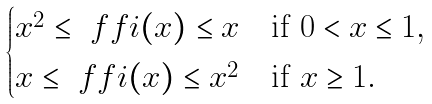Convert formula to latex. <formula><loc_0><loc_0><loc_500><loc_500>\begin{cases} x ^ { 2 } \leq \ f f i ( x ) \leq x & \text {if $0<x\leq1$} , \\ x \leq \ f f i ( x ) \leq x ^ { 2 } & \text {if $x\geq1$} . \end{cases}</formula> 